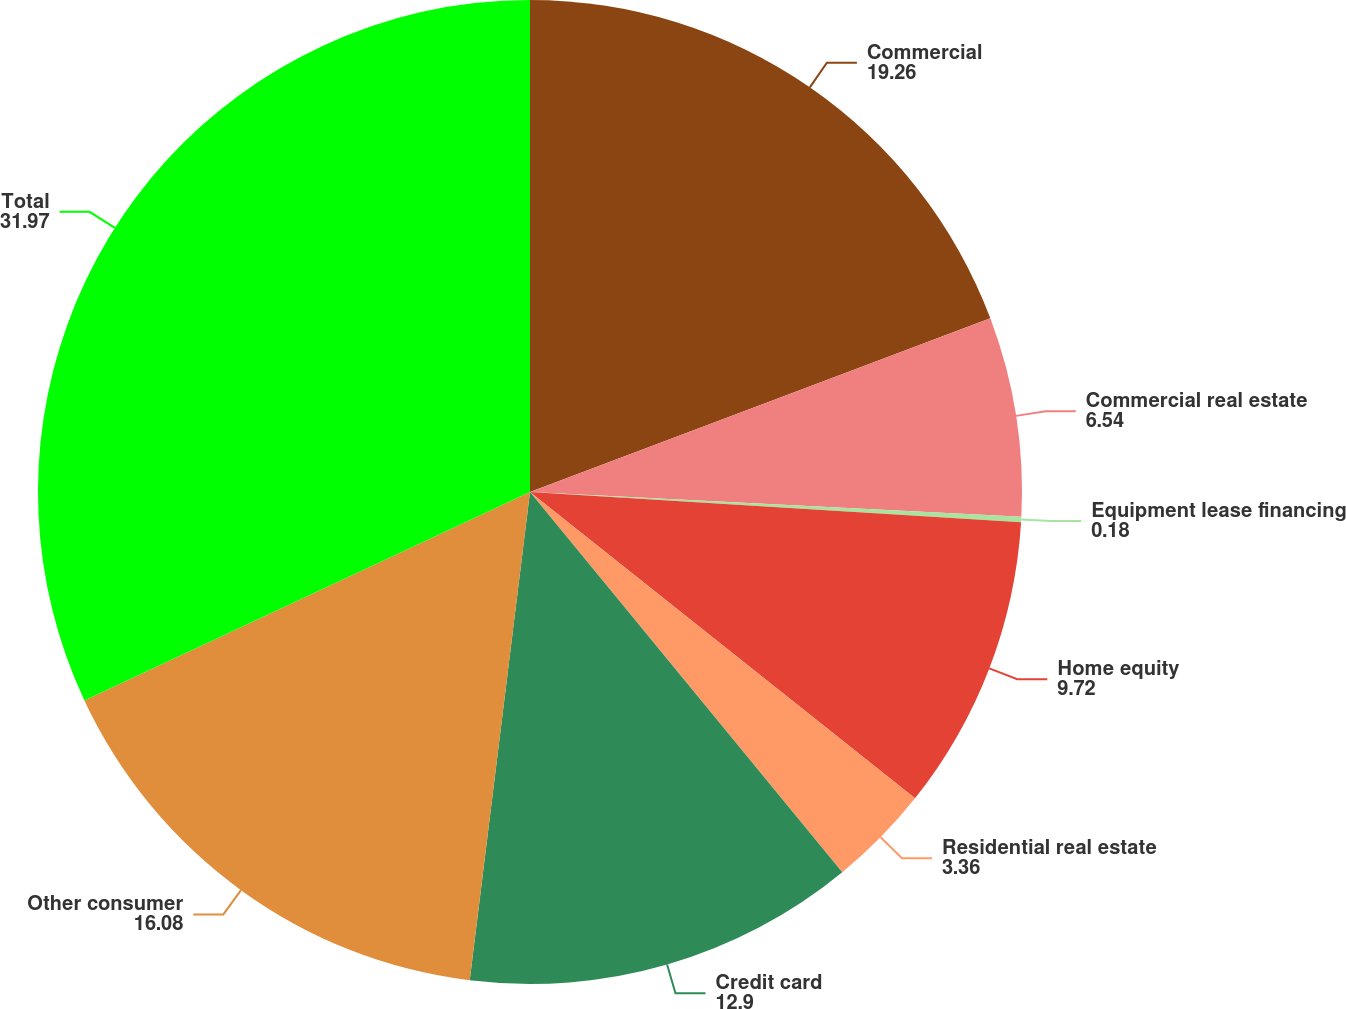Convert chart. <chart><loc_0><loc_0><loc_500><loc_500><pie_chart><fcel>Commercial<fcel>Commercial real estate<fcel>Equipment lease financing<fcel>Home equity<fcel>Residential real estate<fcel>Credit card<fcel>Other consumer<fcel>Total<nl><fcel>19.26%<fcel>6.54%<fcel>0.18%<fcel>9.72%<fcel>3.36%<fcel>12.9%<fcel>16.08%<fcel>31.97%<nl></chart> 